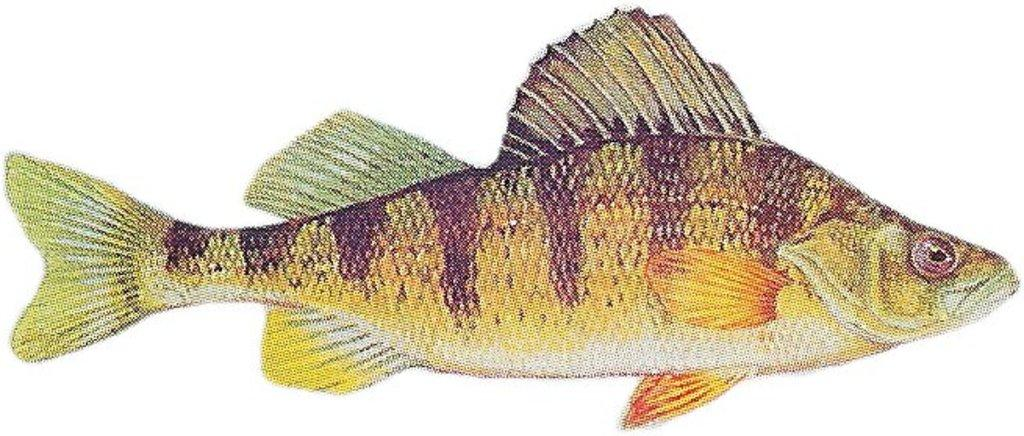What is the main subject of the image? There is a fish in the image. What color is the background of the image? The background of the image is white. Can you see any feet or shoes in the image? There are no feet or shoes present in the image; it features a fish against a white background. 